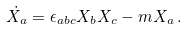<formula> <loc_0><loc_0><loc_500><loc_500>\dot { X _ { a } } = \epsilon _ { a b c } X _ { b } X _ { c } - m X _ { a } \, .</formula> 